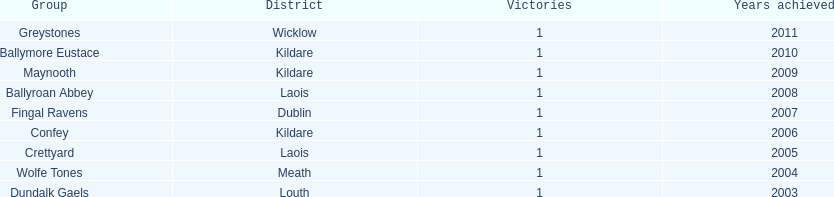What is the number of wins for confey 1. 